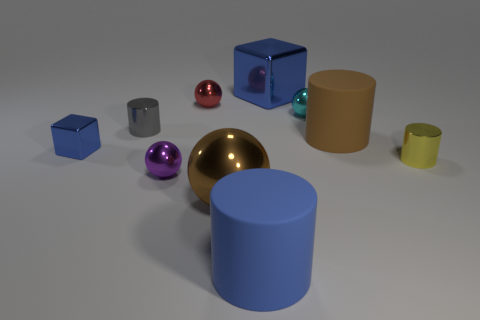Is the red metallic object the same shape as the cyan thing?
Your answer should be compact. Yes. How many brown metal spheres are in front of the gray cylinder that is left of the big sphere?
Provide a succinct answer. 1. The tiny cyan thing that is the same material as the tiny blue thing is what shape?
Give a very brief answer. Sphere. What number of blue things are either shiny blocks or small balls?
Provide a short and direct response. 2. There is a metal thing left of the gray cylinder that is on the left side of the cyan metal sphere; are there any blue blocks that are to the right of it?
Give a very brief answer. Yes. Is the number of large rubber objects less than the number of purple cylinders?
Your answer should be compact. No. There is a big metal object that is behind the tiny cyan object; is it the same shape as the big brown matte thing?
Ensure brevity in your answer.  No. Are there any gray metal things?
Offer a terse response. Yes. What is the color of the large matte cylinder to the left of the big rubber object that is right of the block behind the small blue metal cube?
Keep it short and to the point. Blue. Is the number of large spheres behind the big brown ball the same as the number of metallic cubes to the right of the tiny gray shiny cylinder?
Give a very brief answer. No. 